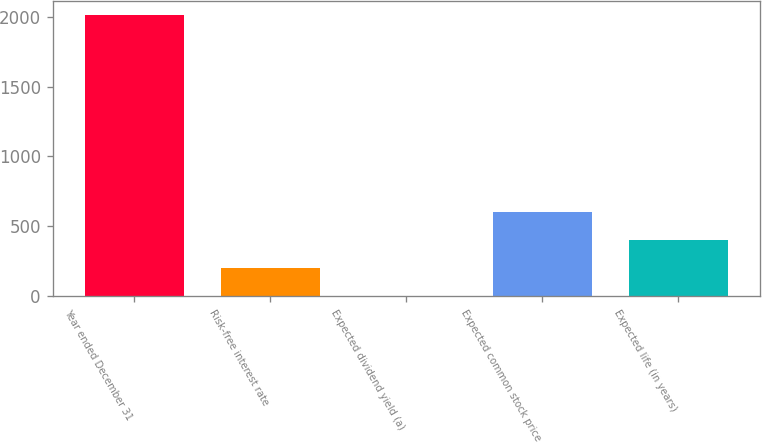Convert chart. <chart><loc_0><loc_0><loc_500><loc_500><bar_chart><fcel>Year ended December 31<fcel>Risk-free interest rate<fcel>Expected dividend yield (a)<fcel>Expected common stock price<fcel>Expected life (in years)<nl><fcel>2011<fcel>203.08<fcel>2.2<fcel>604.84<fcel>403.96<nl></chart> 